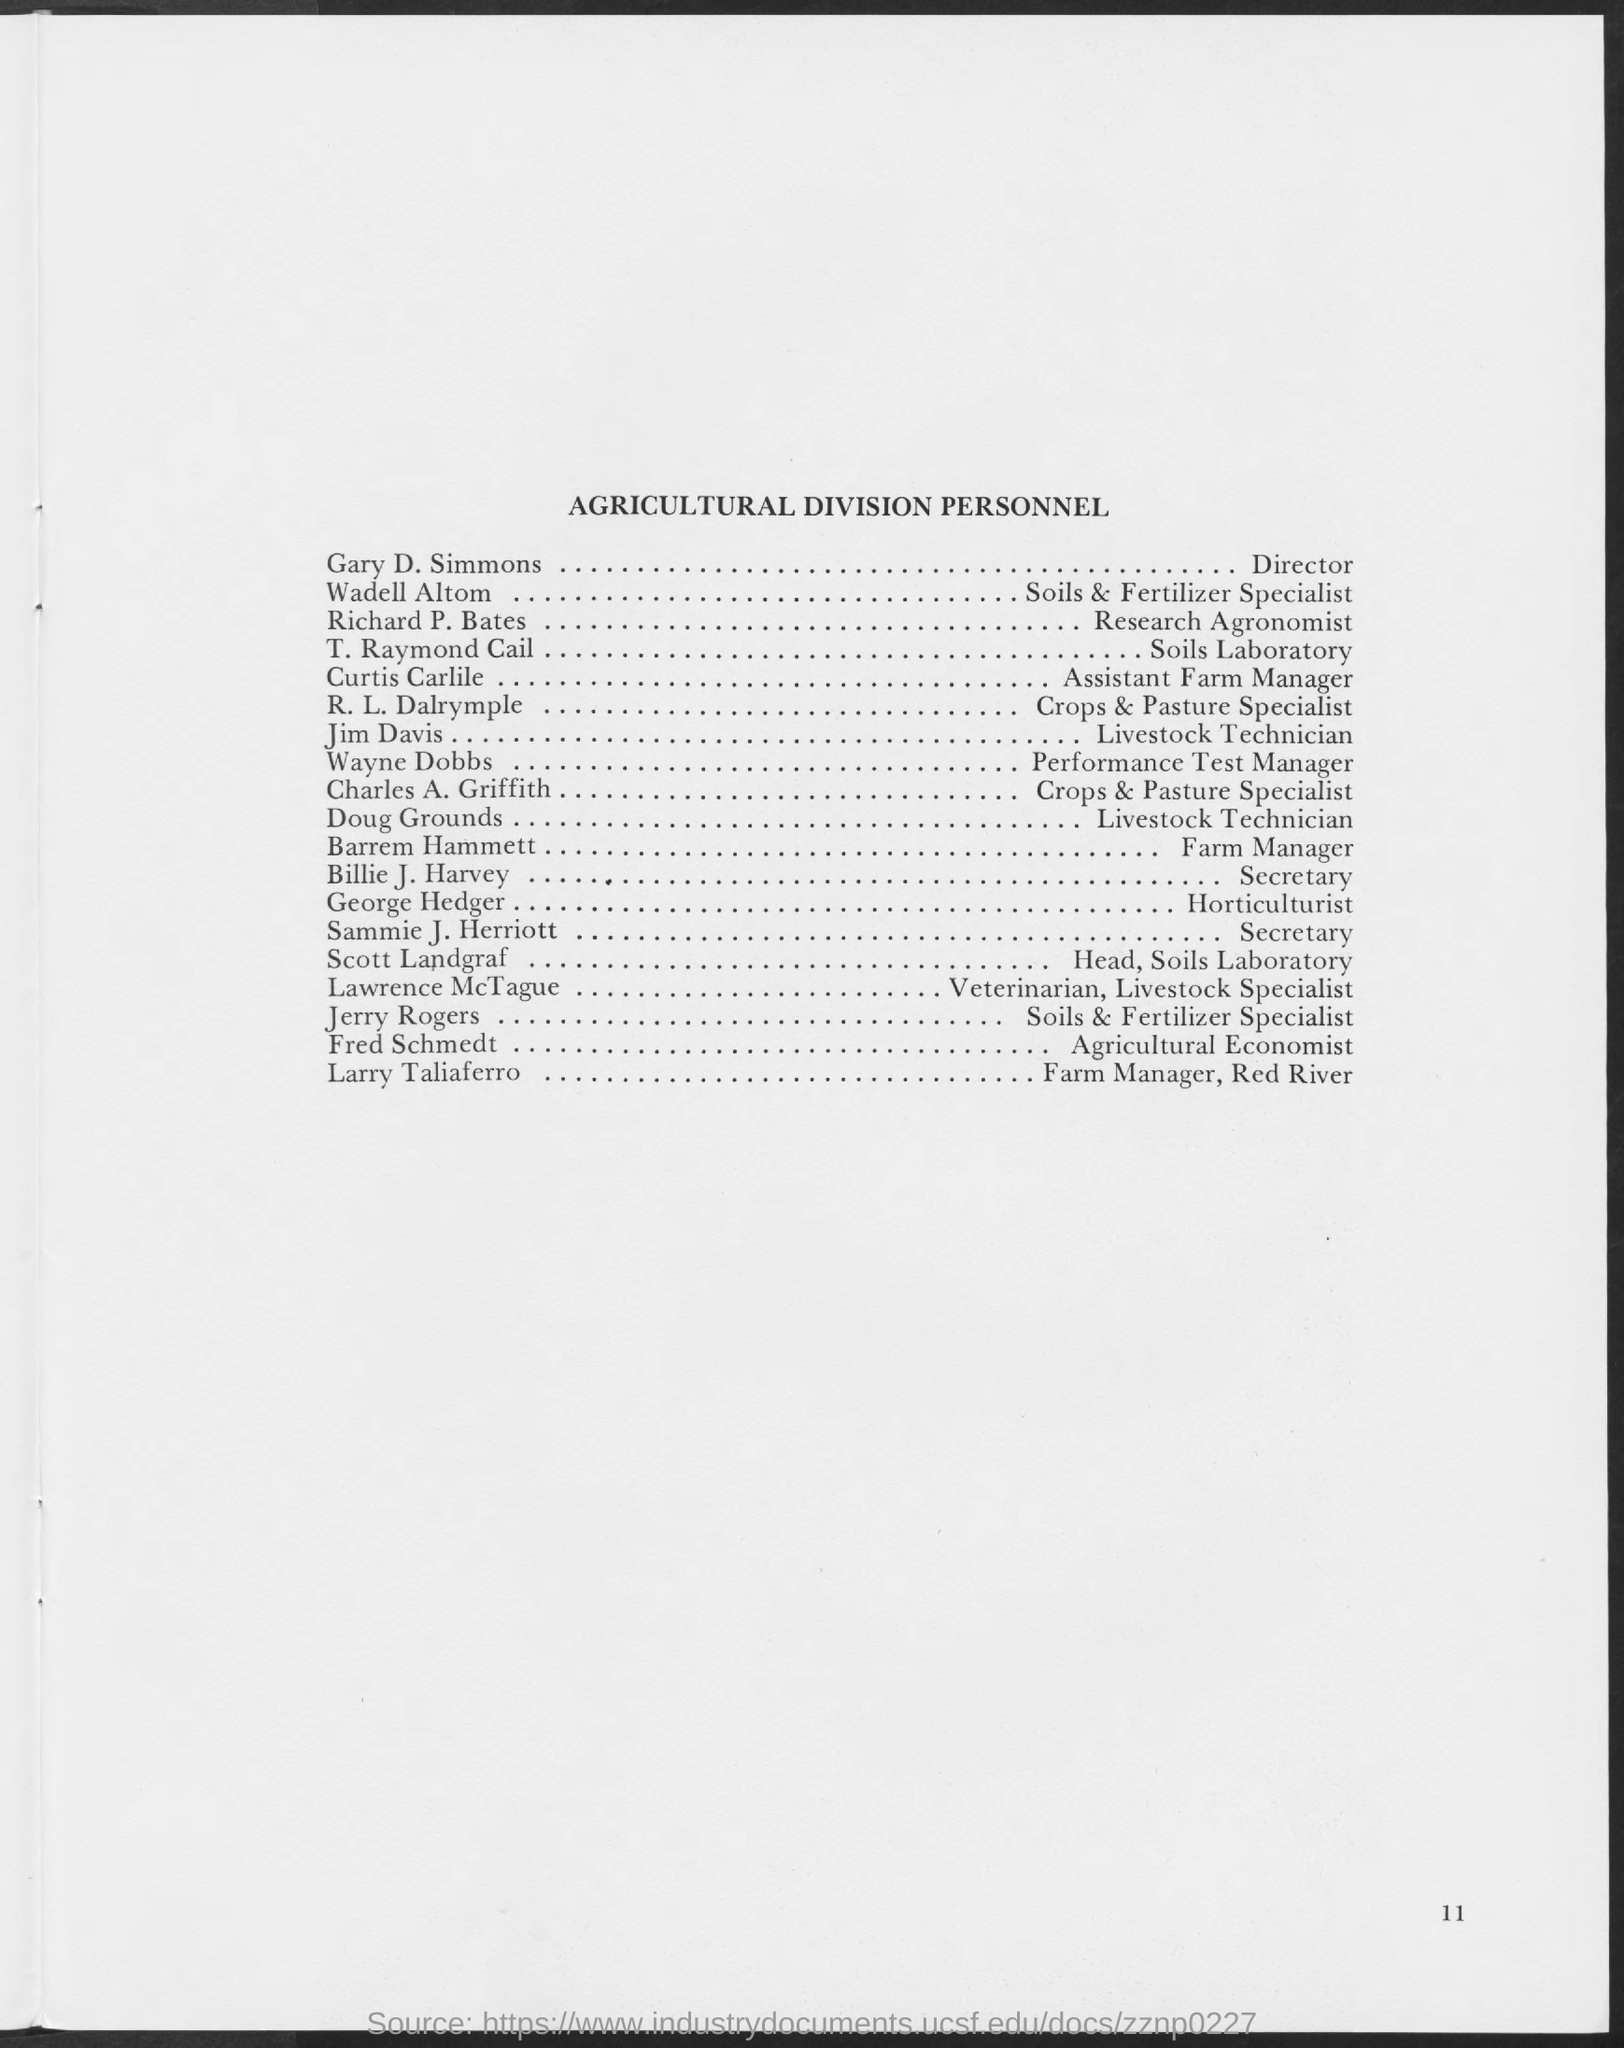Who is the farm manager , red river  of agricultural division personnel
Your answer should be compact. Larry Taliaferro. Who is the agricultural economists
Offer a very short reply. Fred Schmedt. What is the designation of t. raymond cail
Your answer should be compact. Soils laboratory. Who is the assistant farm manager ?
Your response must be concise. Curtis Carlile. What is the designation of wayne dobbs
Give a very brief answer. Performance Test manager. Who is the veterinarian , livestock specialist ?
Your answer should be compact. Lawrence McTague. What is the designation of  richard p. bates
Ensure brevity in your answer.  Research Agronomist. 